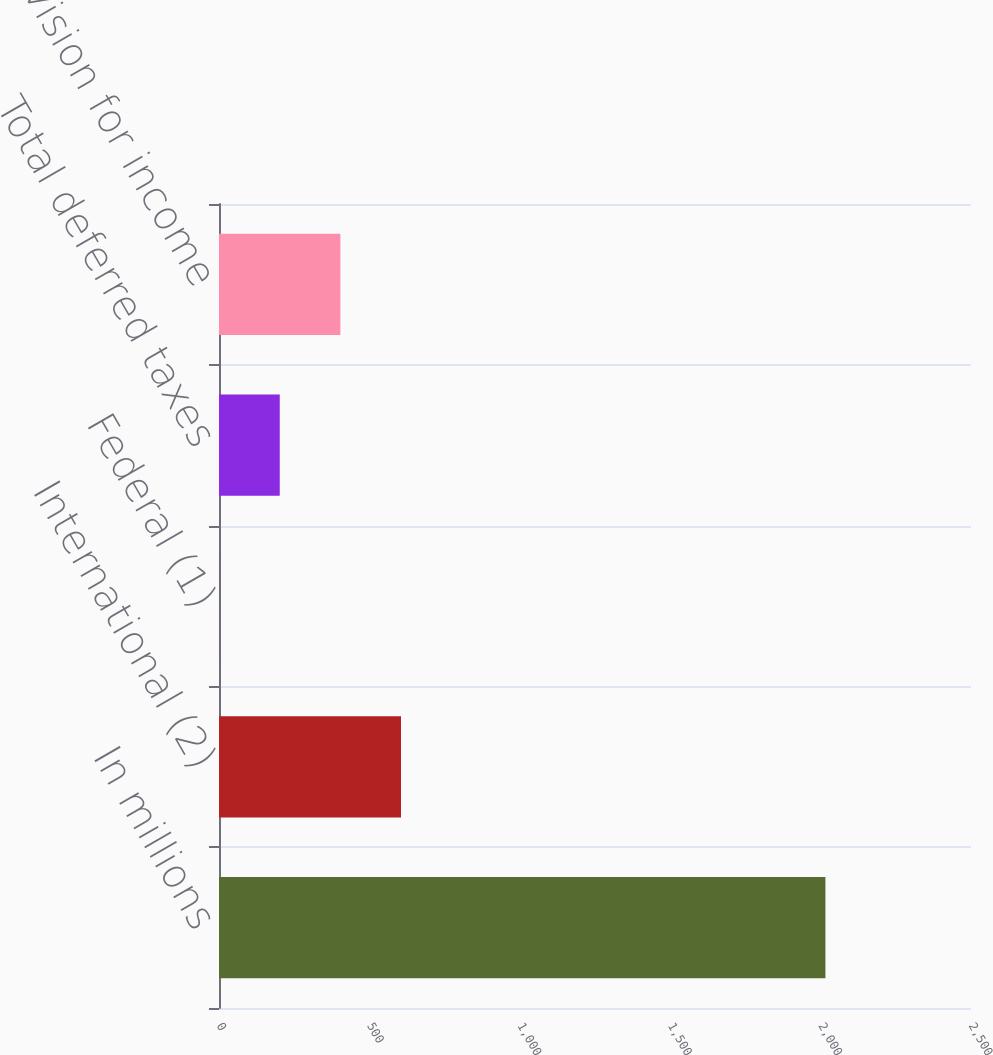Convert chart. <chart><loc_0><loc_0><loc_500><loc_500><bar_chart><fcel>In millions<fcel>International (2)<fcel>Federal (1)<fcel>Total deferred taxes<fcel>Total provision for income<nl><fcel>2016<fcel>605.08<fcel>0.4<fcel>201.96<fcel>403.52<nl></chart> 